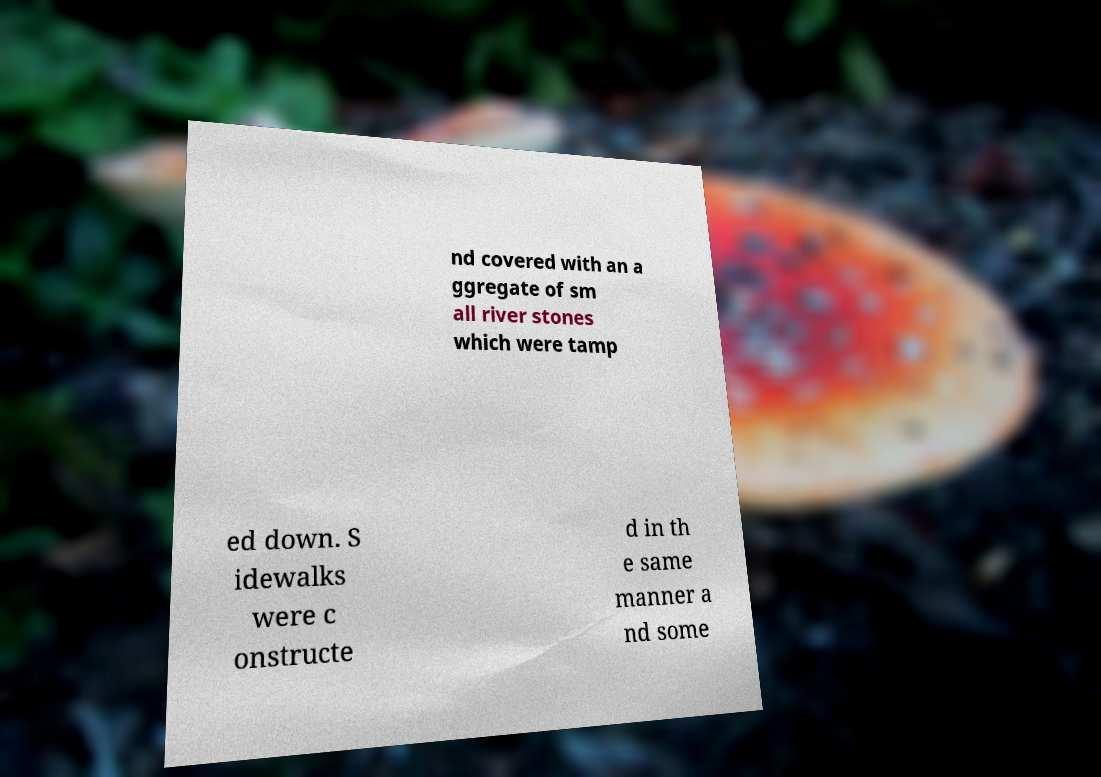What messages or text are displayed in this image? I need them in a readable, typed format. nd covered with an a ggregate of sm all river stones which were tamp ed down. S idewalks were c onstructe d in th e same manner a nd some 